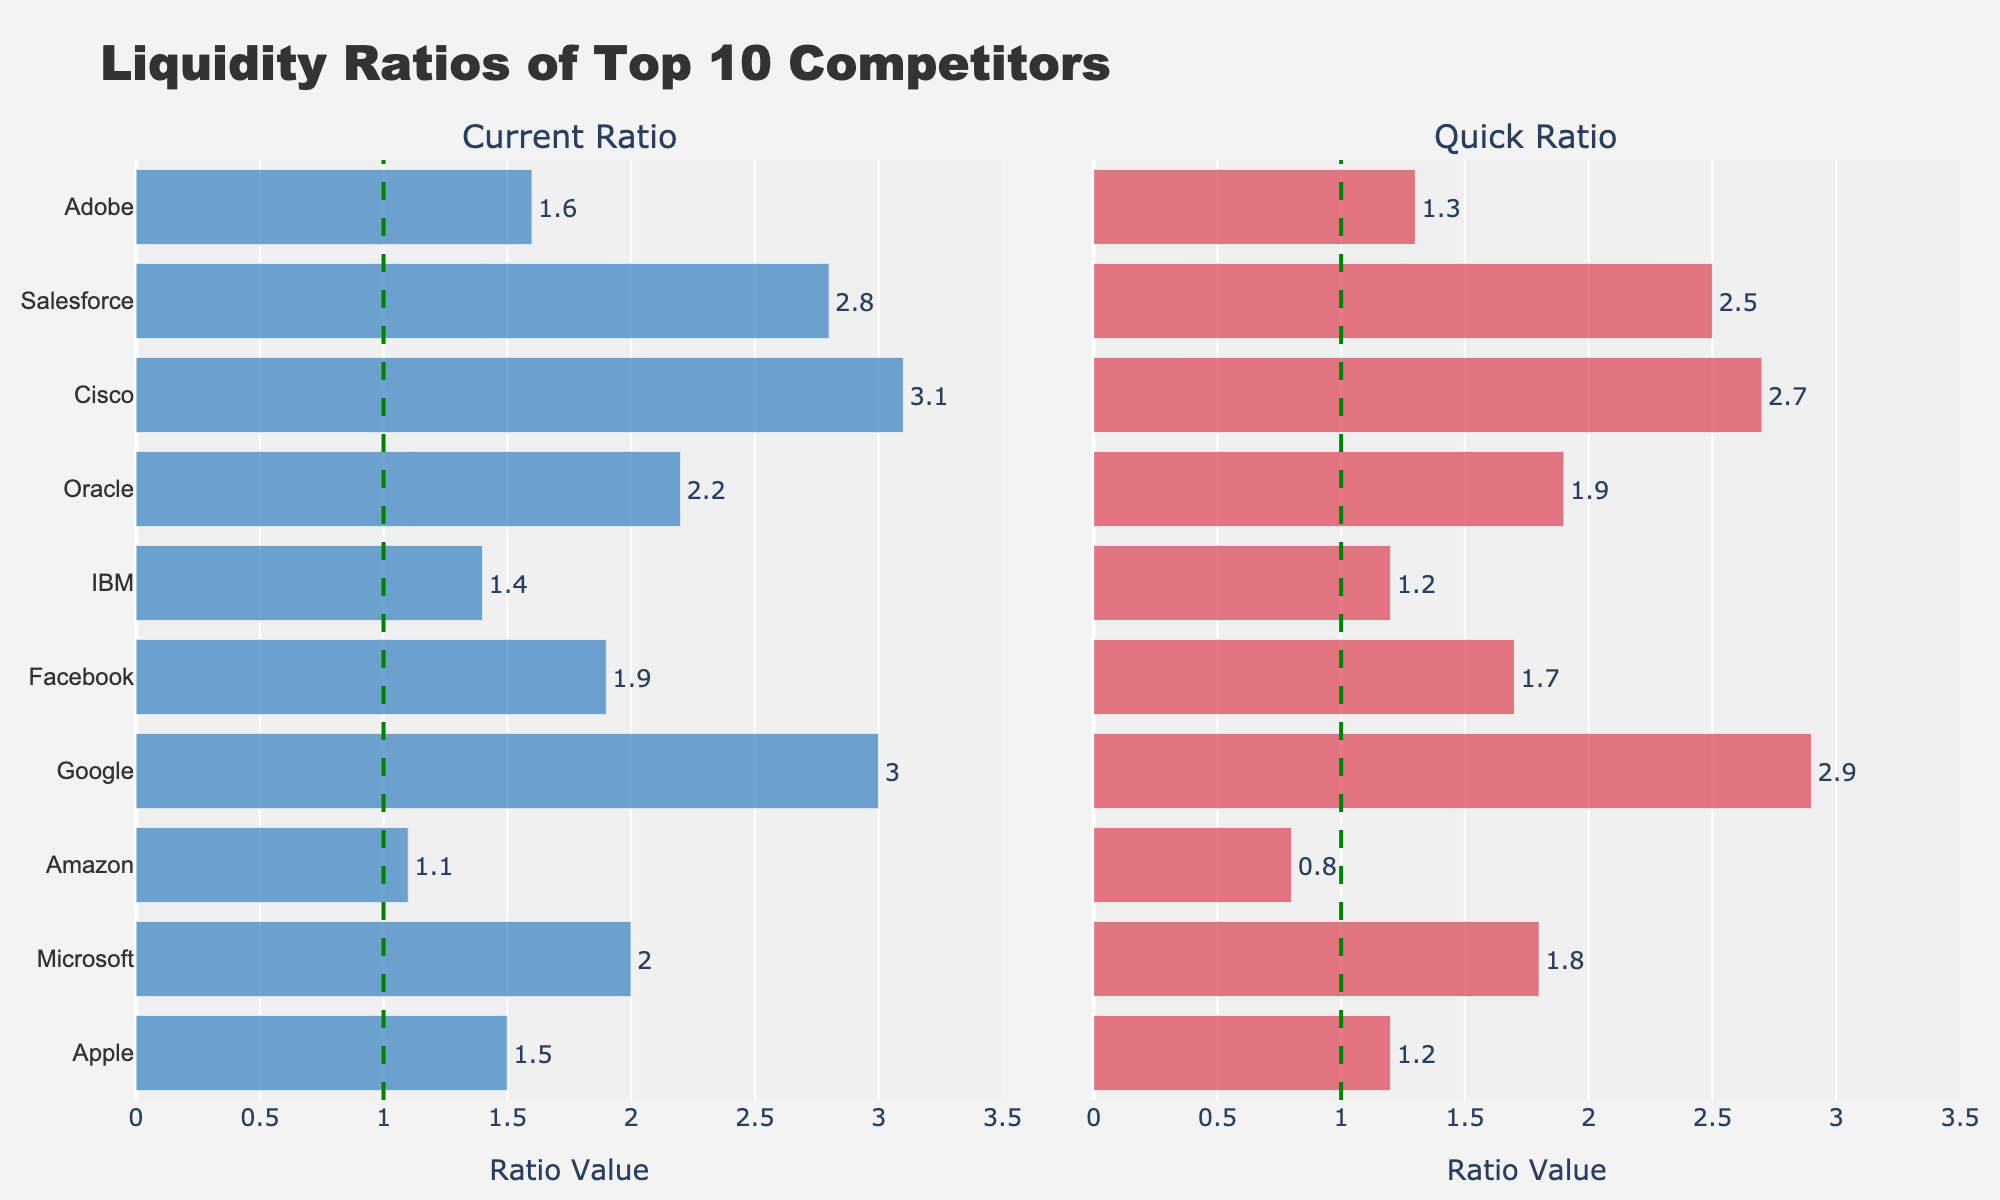Which company has the highest current ratio? The bar for Cisco is the longest in the "Current Ratio" subplot, indicating it has the highest value.
Answer: Cisco What's the difference in the quick ratio between Facebook and Amazon? The quick ratio for Facebook is 1.7 and for Amazon is 0.8. The difference is calculated as 1.7 - 0.8 = 0.9.
Answer: 0.9 How many companies have a current ratio greater than 2.0? Checking the "Current Ratio" subplot, Microsoft, Google, Oracle, Cisco, and Salesforce have ratios greater than 2.0.
Answer: 5 Which company's quick ratio is closer to its current ratio, Google or Adobe? For Google, the quick ratio is 2.9 and the current ratio is 3.0 (difference is 0.1). For Adobe, the quick ratio is 1.3 and the current ratio is 1.6 (difference is 0.3). Therefore, Google's quick ratio is closer to its current ratio.
Answer: Google What's the average current ratio across all companies? Summing all current ratios (1.5 + 2.0 + 1.1 + 3.0 + 1.9 + 1.4 + 2.2 + 3.1 + 2.8 + 1.6) results in 20.6, and there are 10 companies. So, 20.6 / 10 = 2.06.
Answer: 2.06 Which company's quick ratio is less than 1.0? In the "Quick Ratio" subplot, Amazon has a value of 0.8.
Answer: Amazon What's the ratio of current to quick ratio for Oracle? For Oracle, the current ratio is 2.2 and the quick ratio is 1.9. The ratio is 2.2 / 1.9 ≈ 1.16.
Answer: 1.16 Which company has the most significant difference between its current and quick ratios? Cisco has a current ratio of 3.1 and a quick ratio of 2.7, with a difference of 0.4. Google has a similar but slightly smaller difference. Other differences are smaller than 0.4.
Answer: Cisco 